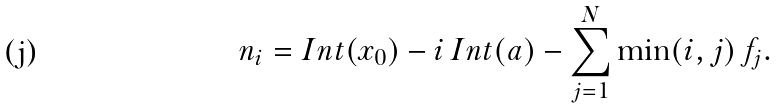Convert formula to latex. <formula><loc_0><loc_0><loc_500><loc_500>n _ { i } = I n t ( x _ { 0 } ) - i \, I n t ( a ) - \sum _ { j = 1 } ^ { N } \min ( i , j ) \, f _ { j } .</formula> 